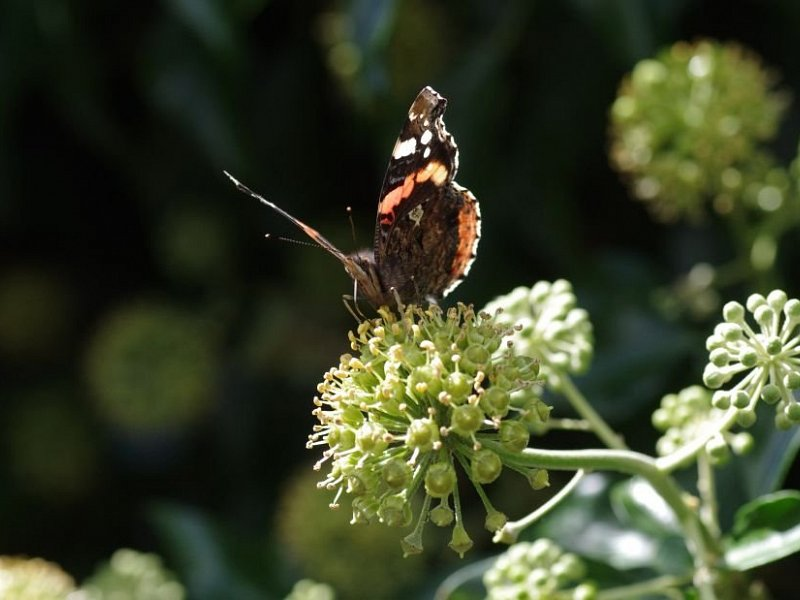Can you describe the butterfly in the image in more detail? The butterfly in the image appears to be a species with beautiful markings. It has dark wings, possibly black, with striking orange and white patterns, particularly noticeable on its upper wings. The butterfly is perched on a flower that is in bloom, suggesting that it is in the midst of feeding on nectar. The intricate patterns and colors are not only visually appealing but also serve as a form of communication and defense. Does the butterfly have any predators, and how does it defend itself? Yes, butterflies have various predators, including birds, spiders, and ants. The butterfly in the image, with its colorful markings, likely uses several defense mechanisms to protect itself. The bright colors can serve as a warning signal to potential predators about its unpalatability, a phenomenon known as aposematism. Some butterflies also have eyespots on their wings, which can confuse or startle predators, allowing them to escape. Additionally, their erratic flight patterns make it more difficult for predators to catch them. 